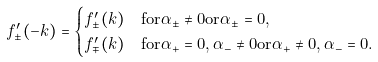<formula> <loc_0><loc_0><loc_500><loc_500>f _ { \pm } ^ { \prime } ( - k ) & = \begin{cases} f _ { \pm } ^ { \prime } ( k ) & \text {for} \alpha _ { \pm } \neq 0 \text {or} \alpha _ { \pm } = 0 , \\ f _ { \mp } ^ { \prime } ( k ) & \text {for} \alpha _ { + } = 0 , \alpha _ { - } \neq 0 \text {or} \alpha _ { + } \neq 0 , \alpha _ { - } = 0 . \end{cases}</formula> 